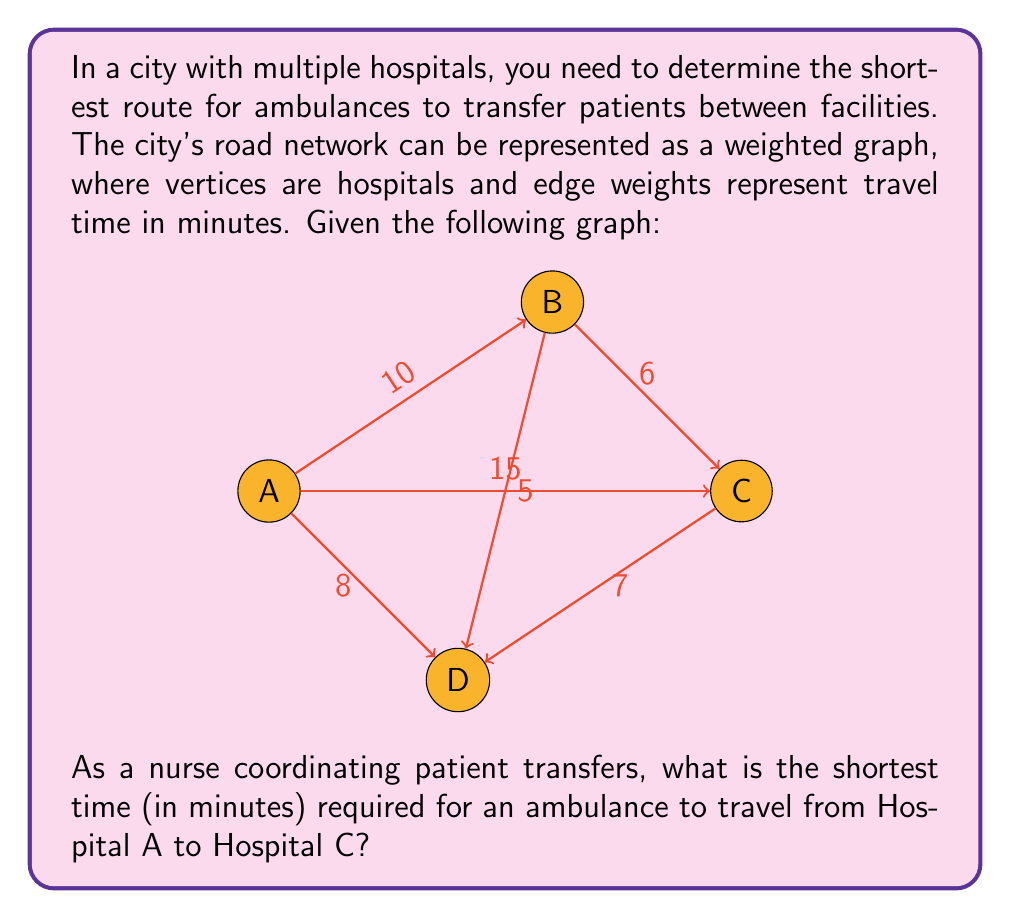Can you solve this math problem? To solve this problem, we need to find the shortest path from Hospital A to Hospital C in the given weighted graph. We can use Dijkstra's algorithm to find the shortest path, but for this small graph, we can also examine all possible paths:

1. Direct path: A → C
   Time: 15 minutes

2. Path through B: A → B → C
   Time: 10 + 6 = 16 minutes

3. Path through D: A → D → C
   Time: 8 + 7 = 15 minutes

4. Path through B and D: A → B → D → C
   Time: 10 + 5 + 7 = 22 minutes

5. Path through D and B: A → D → B → C
   Time: 8 + 5 + 6 = 19 minutes

Comparing all these paths, we can see that there are two shortest paths:
1. The direct path A → C
2. The path A → D → C

Both of these paths take 15 minutes.

As a nurse coordinating patient transfers, you would choose either of these routes to ensure the quickest transfer from Hospital A to Hospital C.
Answer: The shortest time required for an ambulance to travel from Hospital A to Hospital C is 15 minutes. 